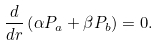<formula> <loc_0><loc_0><loc_500><loc_500>\frac { d } { d r } \left ( \alpha P _ { a } + \beta P _ { b } \right ) = 0 .</formula> 